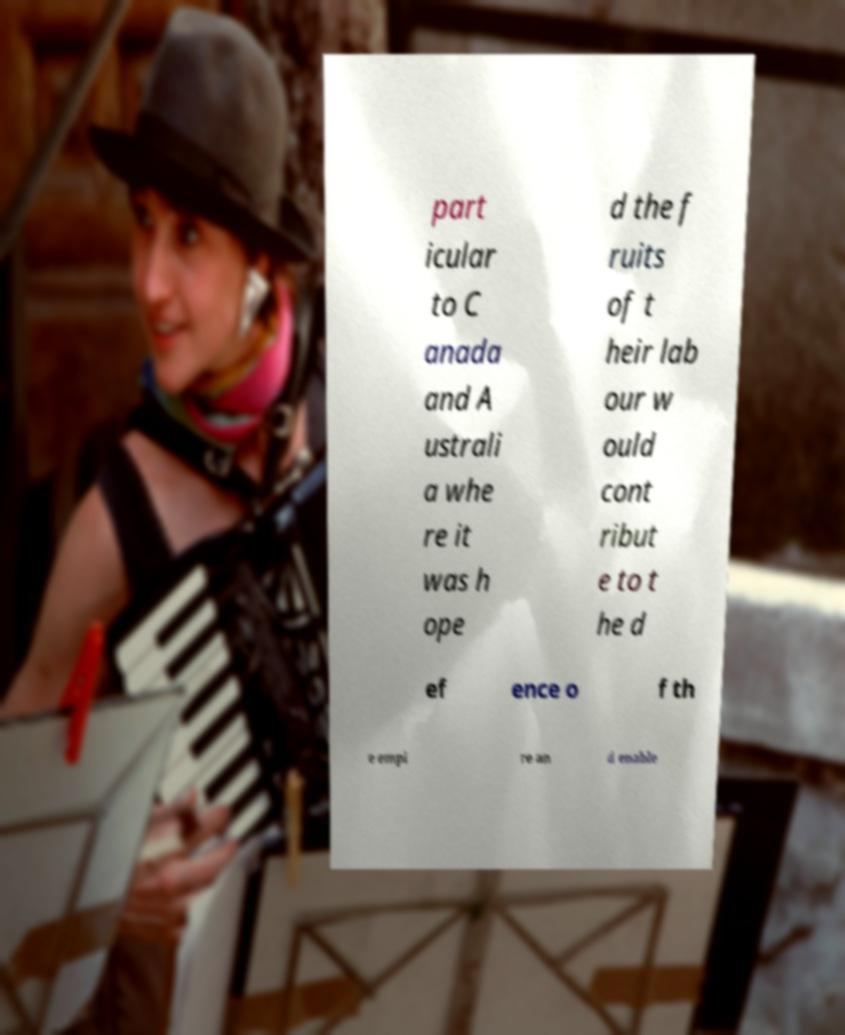There's text embedded in this image that I need extracted. Can you transcribe it verbatim? part icular to C anada and A ustrali a whe re it was h ope d the f ruits of t heir lab our w ould cont ribut e to t he d ef ence o f th e empi re an d enable 